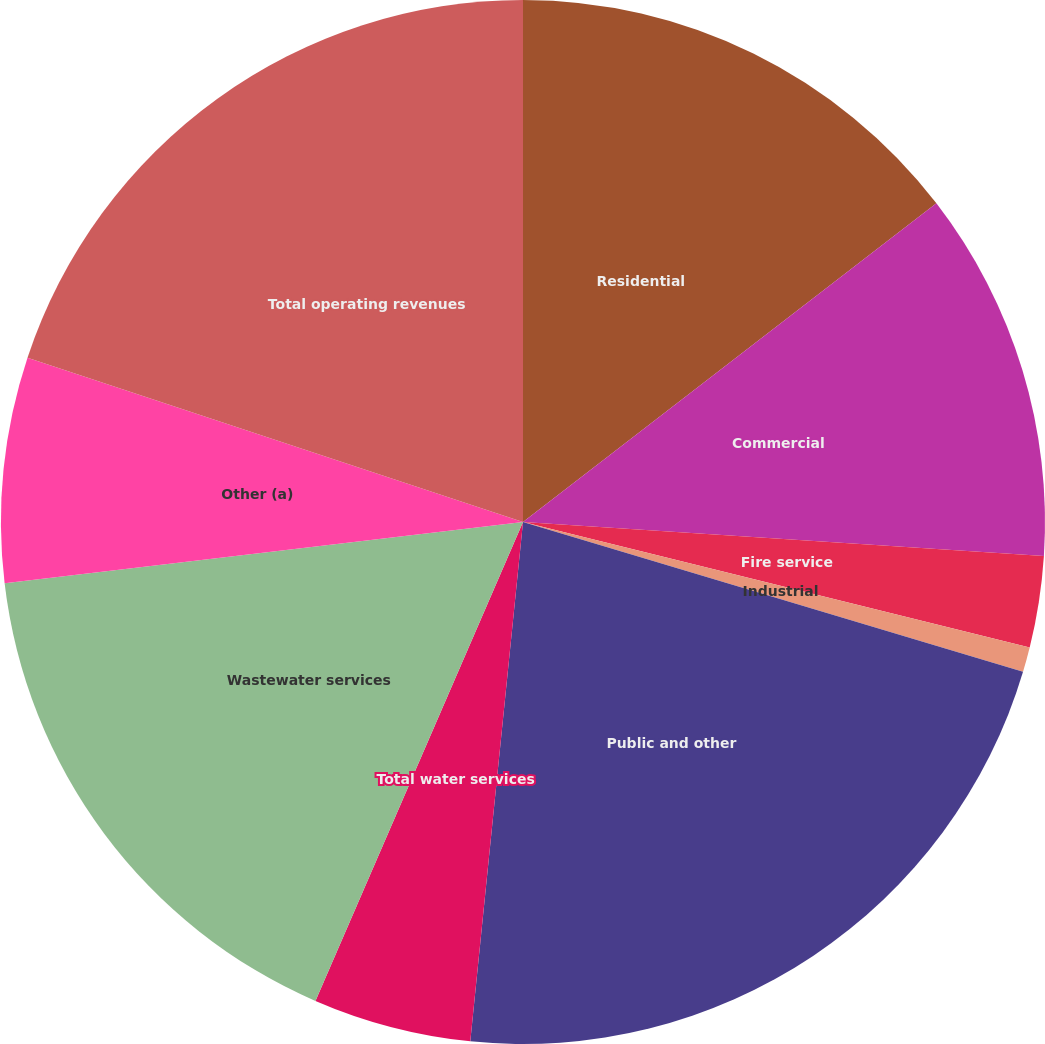Convert chart. <chart><loc_0><loc_0><loc_500><loc_500><pie_chart><fcel>Residential<fcel>Commercial<fcel>Fire service<fcel>Industrial<fcel>Public and other<fcel>Total water services<fcel>Wastewater services<fcel>Other (a)<fcel>Total operating revenues<nl><fcel>14.55%<fcel>11.49%<fcel>2.83%<fcel>0.77%<fcel>21.98%<fcel>4.9%<fcel>16.62%<fcel>6.97%<fcel>19.91%<nl></chart> 